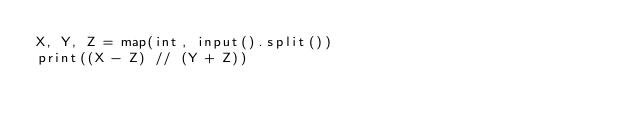Convert code to text. <code><loc_0><loc_0><loc_500><loc_500><_Python_>X, Y, Z = map(int, input().split())
print((X - Z) // (Y + Z))
</code> 